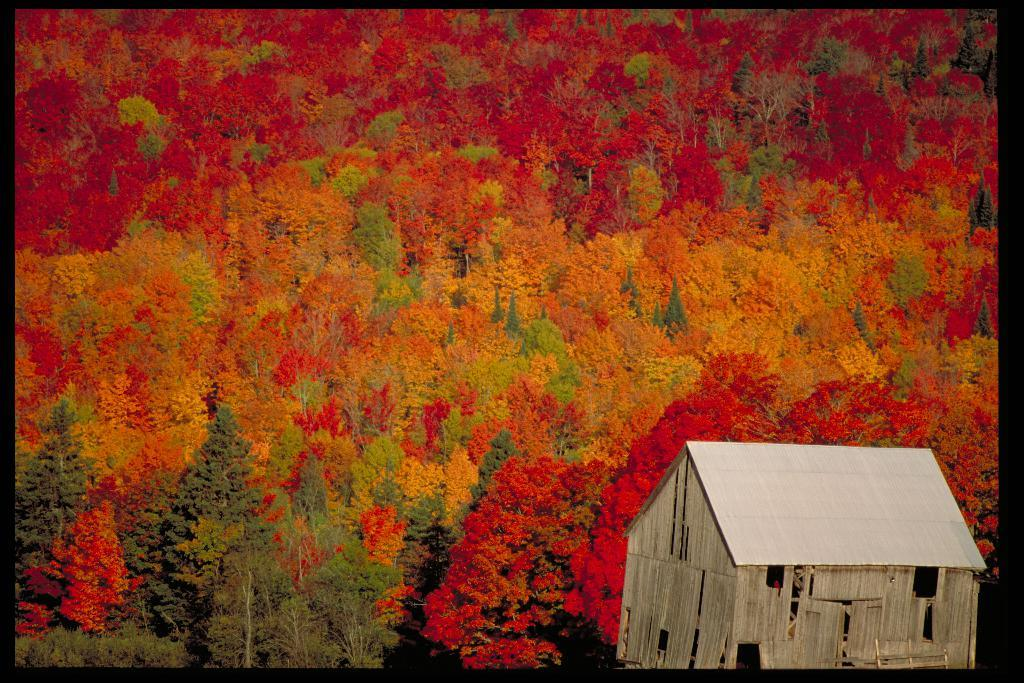What type of structure is present in the image? There is a hut in the image. What can be seen in the background of the image? There are trees in the image. What type of leather is being used to make the hut's roof in the image? There is no leather mentioned or visible in the image; the hut's roof is not described. 